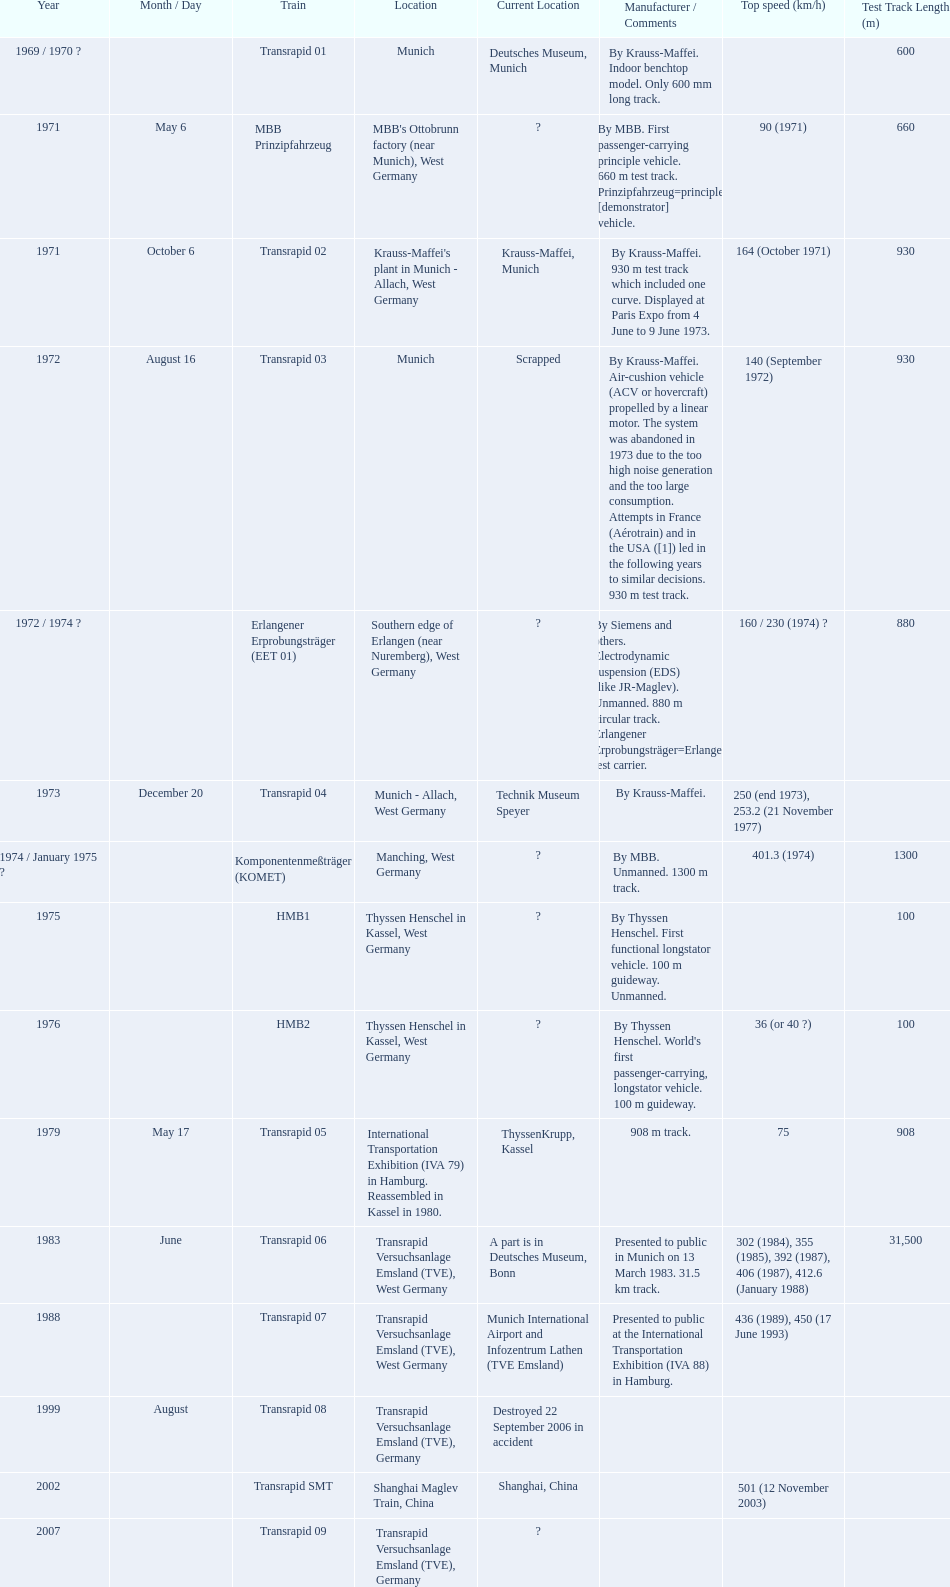What are all of the transrapid trains? Transrapid 01, Transrapid 02, Transrapid 03, Transrapid 04, Transrapid 05, Transrapid 06, Transrapid 07, Transrapid 08, Transrapid SMT, Transrapid 09. Of those, which train had to be scrapped? Transrapid 03. Would you be able to parse every entry in this table? {'header': ['Year', 'Month / Day', 'Train', 'Location', 'Current Location', 'Manufacturer / Comments', 'Top speed (km/h)', 'Test Track Length (m)'], 'rows': [['1969 / 1970 ?', '', 'Transrapid 01', 'Munich', 'Deutsches Museum, Munich', 'By Krauss-Maffei. Indoor benchtop model. Only 600 mm long track.', '', '600'], ['1971', 'May 6', 'MBB Prinzipfahrzeug', "MBB's Ottobrunn factory (near Munich), West Germany", '?', 'By MBB. First passenger-carrying principle vehicle. 660 m test track. Prinzipfahrzeug=principle [demonstrator] vehicle.', '90 (1971)', '660'], ['1971', 'October 6', 'Transrapid 02', "Krauss-Maffei's plant in Munich - Allach, West Germany", 'Krauss-Maffei, Munich', 'By Krauss-Maffei. 930 m test track which included one curve. Displayed at Paris Expo from 4 June to 9 June 1973.', '164 (October 1971)', '930'], ['1972', 'August 16', 'Transrapid 03', 'Munich', 'Scrapped', 'By Krauss-Maffei. Air-cushion vehicle (ACV or hovercraft) propelled by a linear motor. The system was abandoned in 1973 due to the too high noise generation and the too large consumption. Attempts in France (Aérotrain) and in the USA ([1]) led in the following years to similar decisions. 930 m test track.', '140 (September 1972)', '930'], ['1972 / 1974 ?', '', 'Erlangener Erprobungsträger (EET 01)', 'Southern edge of Erlangen (near Nuremberg), West Germany', '?', 'By Siemens and others. Electrodynamic suspension (EDS) (like JR-Maglev). Unmanned. 880 m circular track. Erlangener Erprobungsträger=Erlangen test carrier.', '160 / 230 (1974)\xa0?', '880'], ['1973', 'December 20', 'Transrapid 04', 'Munich - Allach, West Germany', 'Technik Museum Speyer', 'By Krauss-Maffei.', '250 (end 1973), 253.2 (21 November 1977)', ''], ['1974 / January 1975 ?', '', 'Komponentenmeßträger (KOMET)', 'Manching, West Germany', '?', 'By MBB. Unmanned. 1300 m track.', '401.3 (1974)', '1300'], ['1975', '', 'HMB1', 'Thyssen Henschel in Kassel, West Germany', '?', 'By Thyssen Henschel. First functional longstator vehicle. 100 m guideway. Unmanned.', '', '100'], ['1976', '', 'HMB2', 'Thyssen Henschel in Kassel, West Germany', '?', "By Thyssen Henschel. World's first passenger-carrying, longstator vehicle. 100 m guideway.", '36 (or 40\xa0?)', '100'], ['1979', 'May 17', 'Transrapid 05', 'International Transportation Exhibition (IVA 79) in Hamburg. Reassembled in Kassel in 1980.', 'ThyssenKrupp, Kassel', '908 m track.', '75', '908'], ['1983', 'June', 'Transrapid 06', 'Transrapid Versuchsanlage Emsland (TVE), West Germany', 'A part is in Deutsches Museum, Bonn', 'Presented to public in Munich on 13 March 1983. 31.5 km track.', '302 (1984), 355 (1985), 392 (1987), 406 (1987), 412.6 (January 1988)', '31,500'], ['1988', '', 'Transrapid 07', 'Transrapid Versuchsanlage Emsland (TVE), West Germany', 'Munich International Airport and Infozentrum Lathen (TVE Emsland)', 'Presented to public at the International Transportation Exhibition (IVA 88) in Hamburg.', '436 (1989), 450 (17 June 1993)', ''], ['1999', 'August', 'Transrapid 08', 'Transrapid Versuchsanlage Emsland (TVE), Germany', 'Destroyed 22 September 2006 in accident', '', '', ''], ['2002', '', 'Transrapid SMT', 'Shanghai Maglev Train, China', 'Shanghai, China', '', '501 (12 November 2003)', ''], ['2007', '', 'Transrapid 09', 'Transrapid Versuchsanlage Emsland (TVE), Germany', '?', '', '', '']]} 